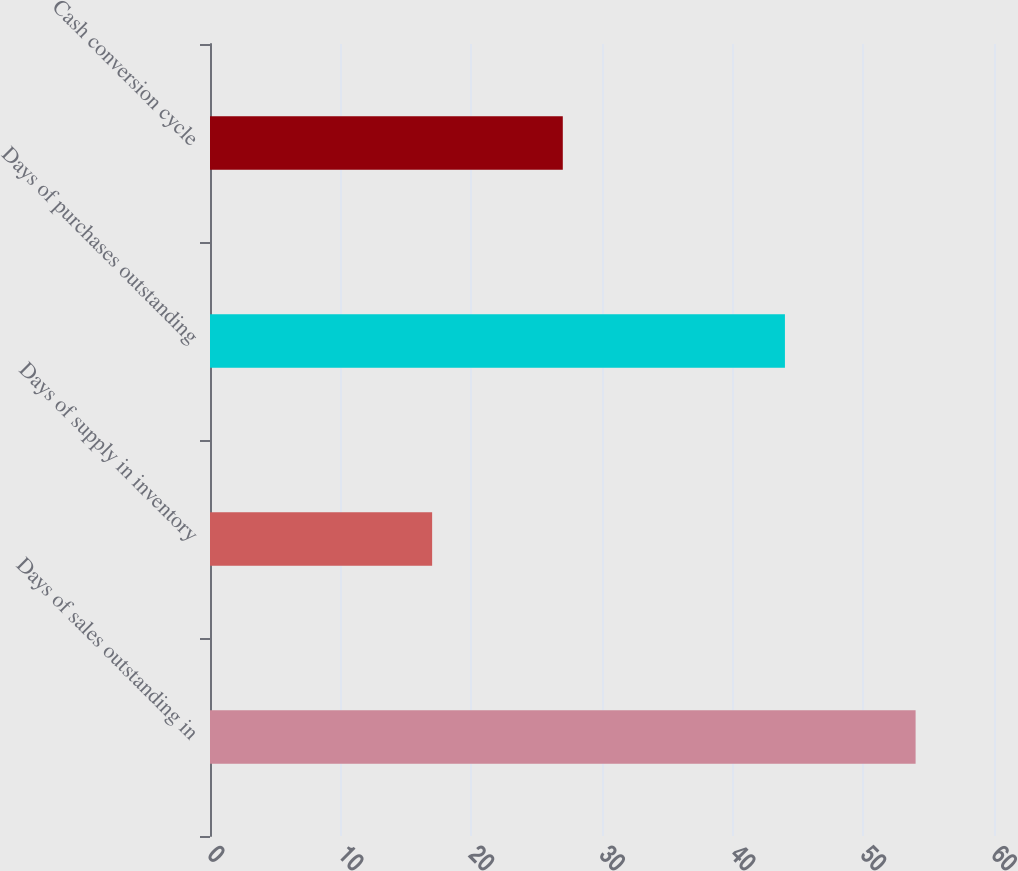Convert chart to OTSL. <chart><loc_0><loc_0><loc_500><loc_500><bar_chart><fcel>Days of sales outstanding in<fcel>Days of supply in inventory<fcel>Days of purchases outstanding<fcel>Cash conversion cycle<nl><fcel>54<fcel>17<fcel>44<fcel>27<nl></chart> 